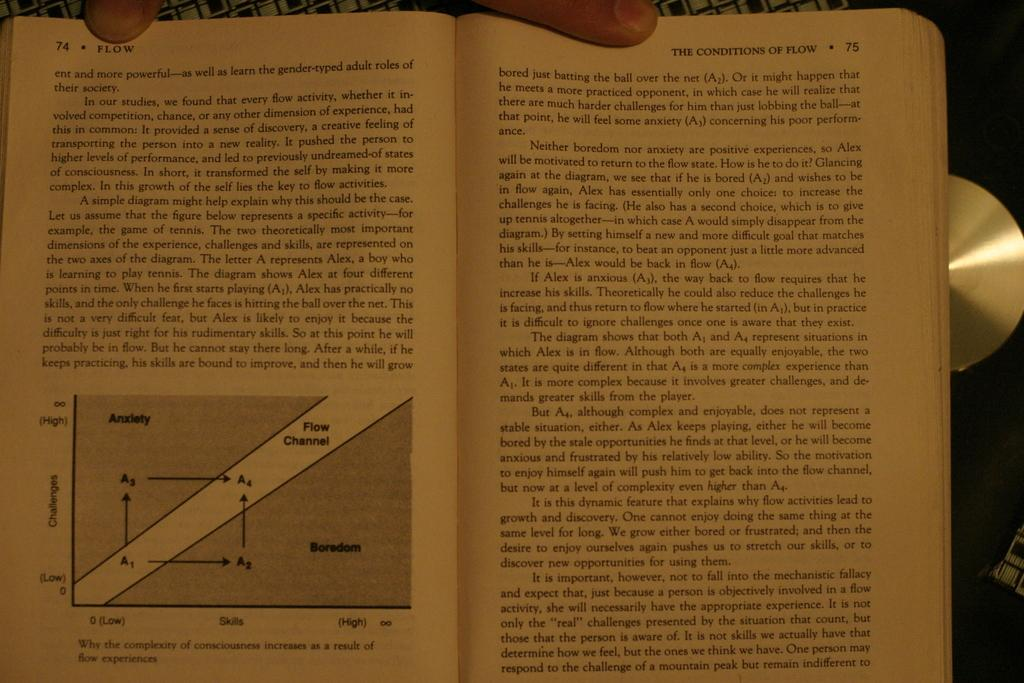Provide a one-sentence caption for the provided image. Pages 74 and 75 of a book discuss the topic of flow. 